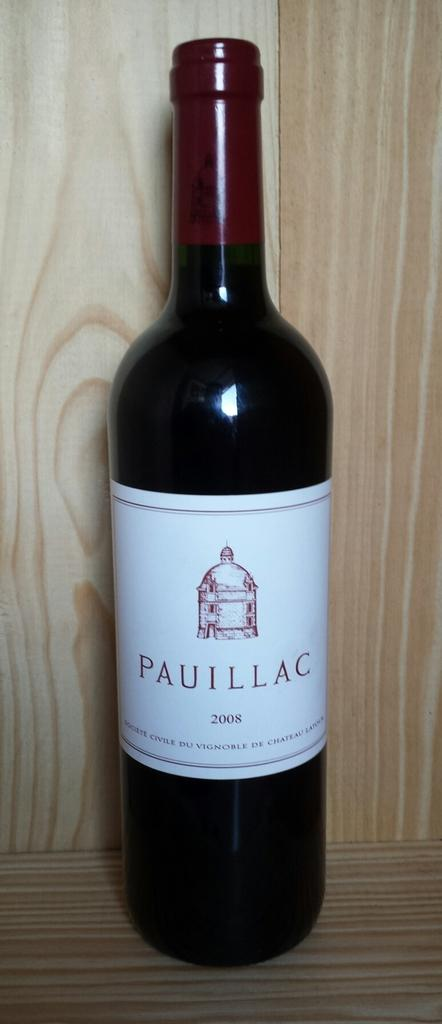Provide a one-sentence caption for the provided image. Bottle of wine the brand is Paullac which is not opened. 